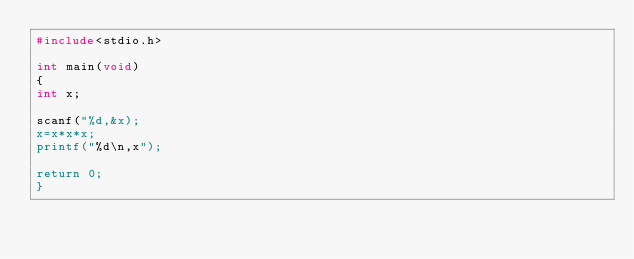<code> <loc_0><loc_0><loc_500><loc_500><_C_>#include<stdio.h>

int main(void)
{
int x;

scanf("%d,&x);
x=x*x*x;
printf("%d\n,x");

return 0;
}</code> 